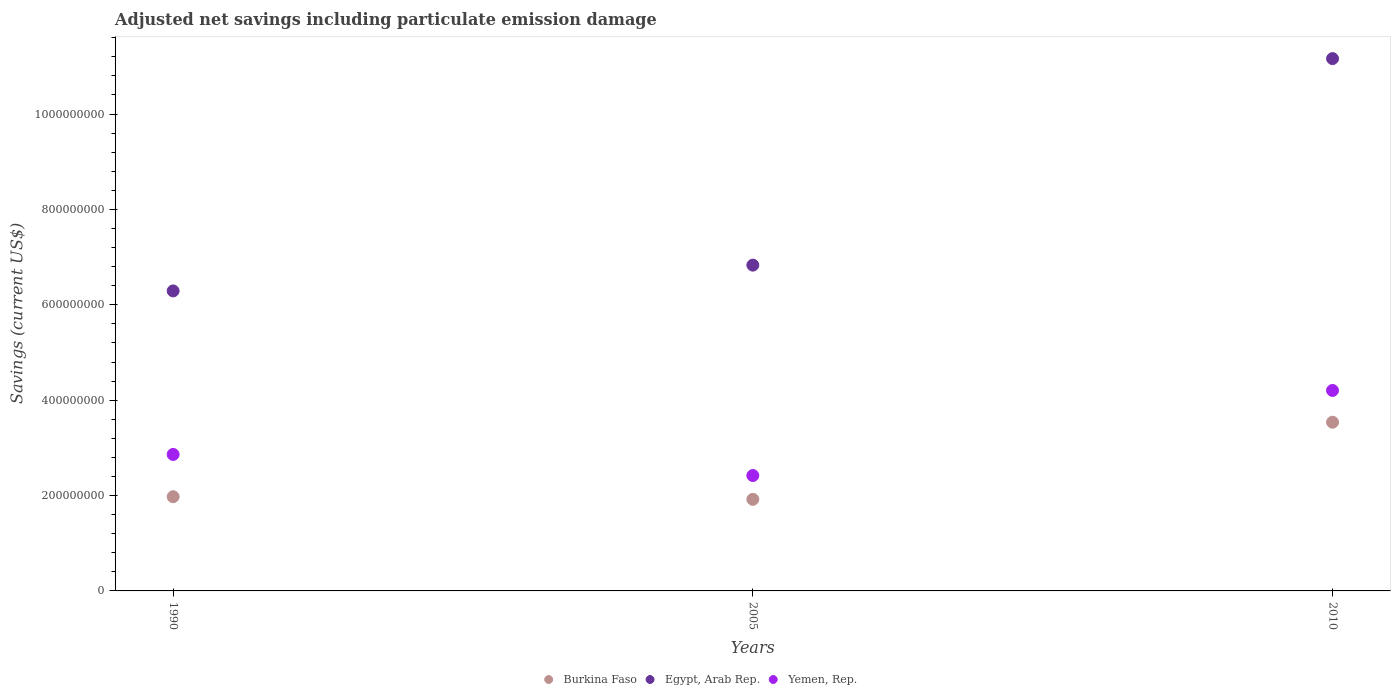Is the number of dotlines equal to the number of legend labels?
Your response must be concise. Yes. What is the net savings in Egypt, Arab Rep. in 1990?
Ensure brevity in your answer.  6.29e+08. Across all years, what is the maximum net savings in Burkina Faso?
Your answer should be very brief. 3.54e+08. Across all years, what is the minimum net savings in Egypt, Arab Rep.?
Give a very brief answer. 6.29e+08. In which year was the net savings in Yemen, Rep. maximum?
Your response must be concise. 2010. In which year was the net savings in Burkina Faso minimum?
Give a very brief answer. 2005. What is the total net savings in Yemen, Rep. in the graph?
Your answer should be compact. 9.49e+08. What is the difference between the net savings in Yemen, Rep. in 1990 and that in 2005?
Give a very brief answer. 4.42e+07. What is the difference between the net savings in Egypt, Arab Rep. in 1990 and the net savings in Burkina Faso in 2010?
Offer a terse response. 2.75e+08. What is the average net savings in Burkina Faso per year?
Make the answer very short. 2.48e+08. In the year 1990, what is the difference between the net savings in Burkina Faso and net savings in Yemen, Rep.?
Ensure brevity in your answer.  -8.86e+07. What is the ratio of the net savings in Yemen, Rep. in 1990 to that in 2005?
Your response must be concise. 1.18. What is the difference between the highest and the second highest net savings in Egypt, Arab Rep.?
Offer a terse response. 4.33e+08. What is the difference between the highest and the lowest net savings in Burkina Faso?
Offer a very short reply. 1.62e+08. In how many years, is the net savings in Egypt, Arab Rep. greater than the average net savings in Egypt, Arab Rep. taken over all years?
Ensure brevity in your answer.  1. Is the sum of the net savings in Yemen, Rep. in 1990 and 2005 greater than the maximum net savings in Burkina Faso across all years?
Offer a very short reply. Yes. Is it the case that in every year, the sum of the net savings in Burkina Faso and net savings in Egypt, Arab Rep.  is greater than the net savings in Yemen, Rep.?
Provide a short and direct response. Yes. Does the net savings in Burkina Faso monotonically increase over the years?
Your answer should be compact. No. Is the net savings in Yemen, Rep. strictly greater than the net savings in Burkina Faso over the years?
Your answer should be compact. Yes. Is the net savings in Egypt, Arab Rep. strictly less than the net savings in Burkina Faso over the years?
Your response must be concise. No. Does the graph contain any zero values?
Ensure brevity in your answer.  No. What is the title of the graph?
Your answer should be compact. Adjusted net savings including particulate emission damage. What is the label or title of the X-axis?
Ensure brevity in your answer.  Years. What is the label or title of the Y-axis?
Your answer should be compact. Savings (current US$). What is the Savings (current US$) of Burkina Faso in 1990?
Provide a short and direct response. 1.98e+08. What is the Savings (current US$) of Egypt, Arab Rep. in 1990?
Give a very brief answer. 6.29e+08. What is the Savings (current US$) of Yemen, Rep. in 1990?
Provide a succinct answer. 2.86e+08. What is the Savings (current US$) in Burkina Faso in 2005?
Provide a succinct answer. 1.92e+08. What is the Savings (current US$) of Egypt, Arab Rep. in 2005?
Provide a short and direct response. 6.83e+08. What is the Savings (current US$) of Yemen, Rep. in 2005?
Your answer should be compact. 2.42e+08. What is the Savings (current US$) of Burkina Faso in 2010?
Provide a short and direct response. 3.54e+08. What is the Savings (current US$) of Egypt, Arab Rep. in 2010?
Make the answer very short. 1.12e+09. What is the Savings (current US$) of Yemen, Rep. in 2010?
Your answer should be very brief. 4.20e+08. Across all years, what is the maximum Savings (current US$) of Burkina Faso?
Your answer should be compact. 3.54e+08. Across all years, what is the maximum Savings (current US$) in Egypt, Arab Rep.?
Make the answer very short. 1.12e+09. Across all years, what is the maximum Savings (current US$) of Yemen, Rep.?
Your answer should be very brief. 4.20e+08. Across all years, what is the minimum Savings (current US$) in Burkina Faso?
Ensure brevity in your answer.  1.92e+08. Across all years, what is the minimum Savings (current US$) of Egypt, Arab Rep.?
Your answer should be compact. 6.29e+08. Across all years, what is the minimum Savings (current US$) in Yemen, Rep.?
Give a very brief answer. 2.42e+08. What is the total Savings (current US$) in Burkina Faso in the graph?
Your response must be concise. 7.43e+08. What is the total Savings (current US$) in Egypt, Arab Rep. in the graph?
Your answer should be very brief. 2.43e+09. What is the total Savings (current US$) of Yemen, Rep. in the graph?
Make the answer very short. 9.49e+08. What is the difference between the Savings (current US$) of Burkina Faso in 1990 and that in 2005?
Keep it short and to the point. 5.55e+06. What is the difference between the Savings (current US$) in Egypt, Arab Rep. in 1990 and that in 2005?
Your answer should be very brief. -5.41e+07. What is the difference between the Savings (current US$) in Yemen, Rep. in 1990 and that in 2005?
Make the answer very short. 4.42e+07. What is the difference between the Savings (current US$) in Burkina Faso in 1990 and that in 2010?
Your response must be concise. -1.56e+08. What is the difference between the Savings (current US$) in Egypt, Arab Rep. in 1990 and that in 2010?
Offer a very short reply. -4.87e+08. What is the difference between the Savings (current US$) of Yemen, Rep. in 1990 and that in 2010?
Make the answer very short. -1.34e+08. What is the difference between the Savings (current US$) in Burkina Faso in 2005 and that in 2010?
Make the answer very short. -1.62e+08. What is the difference between the Savings (current US$) of Egypt, Arab Rep. in 2005 and that in 2010?
Provide a short and direct response. -4.33e+08. What is the difference between the Savings (current US$) in Yemen, Rep. in 2005 and that in 2010?
Give a very brief answer. -1.78e+08. What is the difference between the Savings (current US$) of Burkina Faso in 1990 and the Savings (current US$) of Egypt, Arab Rep. in 2005?
Offer a terse response. -4.86e+08. What is the difference between the Savings (current US$) of Burkina Faso in 1990 and the Savings (current US$) of Yemen, Rep. in 2005?
Your answer should be compact. -4.44e+07. What is the difference between the Savings (current US$) of Egypt, Arab Rep. in 1990 and the Savings (current US$) of Yemen, Rep. in 2005?
Make the answer very short. 3.87e+08. What is the difference between the Savings (current US$) of Burkina Faso in 1990 and the Savings (current US$) of Egypt, Arab Rep. in 2010?
Your answer should be very brief. -9.19e+08. What is the difference between the Savings (current US$) in Burkina Faso in 1990 and the Savings (current US$) in Yemen, Rep. in 2010?
Keep it short and to the point. -2.23e+08. What is the difference between the Savings (current US$) in Egypt, Arab Rep. in 1990 and the Savings (current US$) in Yemen, Rep. in 2010?
Ensure brevity in your answer.  2.09e+08. What is the difference between the Savings (current US$) of Burkina Faso in 2005 and the Savings (current US$) of Egypt, Arab Rep. in 2010?
Your answer should be very brief. -9.24e+08. What is the difference between the Savings (current US$) of Burkina Faso in 2005 and the Savings (current US$) of Yemen, Rep. in 2010?
Your response must be concise. -2.28e+08. What is the difference between the Savings (current US$) in Egypt, Arab Rep. in 2005 and the Savings (current US$) in Yemen, Rep. in 2010?
Make the answer very short. 2.63e+08. What is the average Savings (current US$) in Burkina Faso per year?
Make the answer very short. 2.48e+08. What is the average Savings (current US$) in Egypt, Arab Rep. per year?
Provide a succinct answer. 8.10e+08. What is the average Savings (current US$) of Yemen, Rep. per year?
Offer a very short reply. 3.16e+08. In the year 1990, what is the difference between the Savings (current US$) in Burkina Faso and Savings (current US$) in Egypt, Arab Rep.?
Your response must be concise. -4.32e+08. In the year 1990, what is the difference between the Savings (current US$) in Burkina Faso and Savings (current US$) in Yemen, Rep.?
Your response must be concise. -8.86e+07. In the year 1990, what is the difference between the Savings (current US$) of Egypt, Arab Rep. and Savings (current US$) of Yemen, Rep.?
Provide a succinct answer. 3.43e+08. In the year 2005, what is the difference between the Savings (current US$) in Burkina Faso and Savings (current US$) in Egypt, Arab Rep.?
Provide a succinct answer. -4.91e+08. In the year 2005, what is the difference between the Savings (current US$) of Burkina Faso and Savings (current US$) of Yemen, Rep.?
Your response must be concise. -5.00e+07. In the year 2005, what is the difference between the Savings (current US$) in Egypt, Arab Rep. and Savings (current US$) in Yemen, Rep.?
Provide a short and direct response. 4.41e+08. In the year 2010, what is the difference between the Savings (current US$) of Burkina Faso and Savings (current US$) of Egypt, Arab Rep.?
Your response must be concise. -7.63e+08. In the year 2010, what is the difference between the Savings (current US$) in Burkina Faso and Savings (current US$) in Yemen, Rep.?
Make the answer very short. -6.67e+07. In the year 2010, what is the difference between the Savings (current US$) of Egypt, Arab Rep. and Savings (current US$) of Yemen, Rep.?
Keep it short and to the point. 6.96e+08. What is the ratio of the Savings (current US$) in Burkina Faso in 1990 to that in 2005?
Make the answer very short. 1.03. What is the ratio of the Savings (current US$) of Egypt, Arab Rep. in 1990 to that in 2005?
Ensure brevity in your answer.  0.92. What is the ratio of the Savings (current US$) of Yemen, Rep. in 1990 to that in 2005?
Give a very brief answer. 1.18. What is the ratio of the Savings (current US$) of Burkina Faso in 1990 to that in 2010?
Offer a very short reply. 0.56. What is the ratio of the Savings (current US$) in Egypt, Arab Rep. in 1990 to that in 2010?
Make the answer very short. 0.56. What is the ratio of the Savings (current US$) of Yemen, Rep. in 1990 to that in 2010?
Provide a succinct answer. 0.68. What is the ratio of the Savings (current US$) in Burkina Faso in 2005 to that in 2010?
Your answer should be very brief. 0.54. What is the ratio of the Savings (current US$) of Egypt, Arab Rep. in 2005 to that in 2010?
Offer a terse response. 0.61. What is the ratio of the Savings (current US$) in Yemen, Rep. in 2005 to that in 2010?
Your answer should be compact. 0.58. What is the difference between the highest and the second highest Savings (current US$) of Burkina Faso?
Your answer should be very brief. 1.56e+08. What is the difference between the highest and the second highest Savings (current US$) in Egypt, Arab Rep.?
Provide a short and direct response. 4.33e+08. What is the difference between the highest and the second highest Savings (current US$) of Yemen, Rep.?
Keep it short and to the point. 1.34e+08. What is the difference between the highest and the lowest Savings (current US$) of Burkina Faso?
Provide a succinct answer. 1.62e+08. What is the difference between the highest and the lowest Savings (current US$) in Egypt, Arab Rep.?
Keep it short and to the point. 4.87e+08. What is the difference between the highest and the lowest Savings (current US$) in Yemen, Rep.?
Keep it short and to the point. 1.78e+08. 